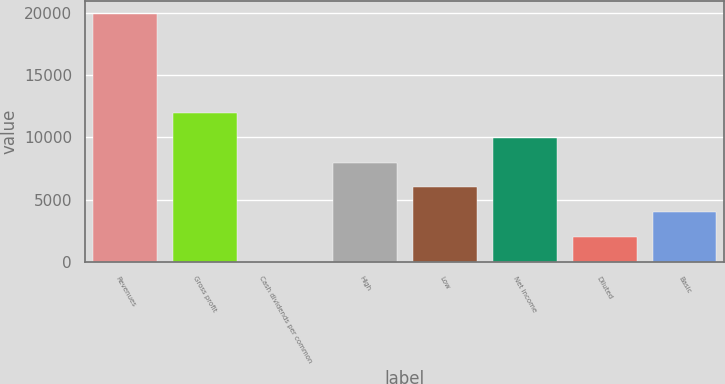<chart> <loc_0><loc_0><loc_500><loc_500><bar_chart><fcel>Revenues<fcel>Gross profit<fcel>Cash dividends per common<fcel>High<fcel>Low<fcel>Net income<fcel>Diluted<fcel>Basic<nl><fcel>19934.3<fcel>11960.6<fcel>0.06<fcel>7973.74<fcel>5980.32<fcel>9967.16<fcel>1993.48<fcel>3986.9<nl></chart> 